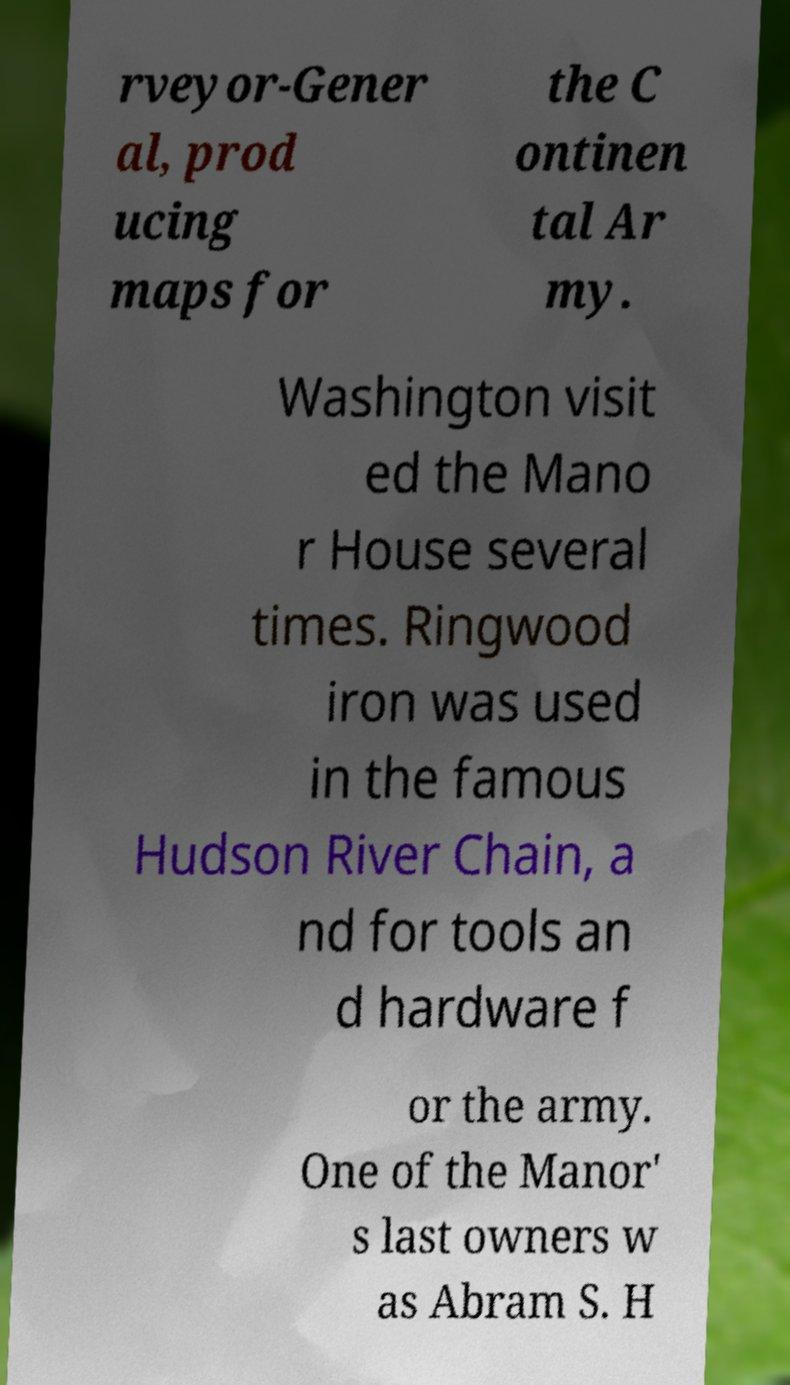Please read and relay the text visible in this image. What does it say? rveyor-Gener al, prod ucing maps for the C ontinen tal Ar my. Washington visit ed the Mano r House several times. Ringwood iron was used in the famous Hudson River Chain, a nd for tools an d hardware f or the army. One of the Manor' s last owners w as Abram S. H 